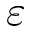<formula> <loc_0><loc_0><loc_500><loc_500>\varepsilon</formula> 